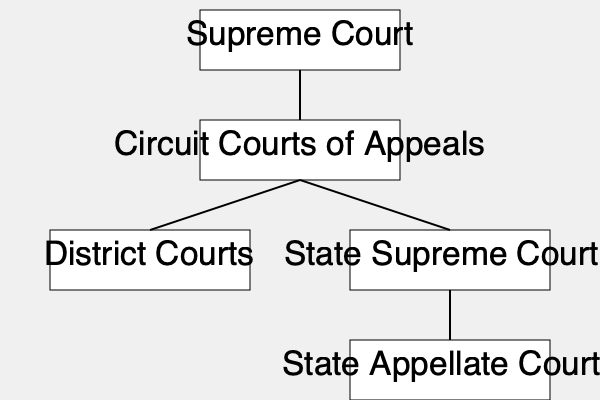Based on the flow chart of the U.S. court system, which court would hear an appeal from a decision made by a U.S. District Court? To answer this question, we need to understand the hierarchy of the U.S. court system as shown in the flow chart:

1. The flow chart shows the Supreme Court at the top, indicating it's the highest court in the land.

2. Directly below the Supreme Court are the Circuit Courts of Appeals.

3. Below the Circuit Courts of Appeals, we see two parallel courts: District Courts and State Supreme Courts.

4. The question asks about an appeal from a U.S. District Court decision.

5. In the federal court system, appeals from District Courts go to the next higher level, which is the Circuit Courts of Appeals.

6. The flow chart correctly shows an arrow connecting the District Courts to the Circuit Courts of Appeals, confirming this relationship.

Therefore, based on the flow chart and the structure of the U.S. federal court system, an appeal from a U.S. District Court would be heard by a Circuit Court of Appeals.
Answer: Circuit Courts of Appeals 